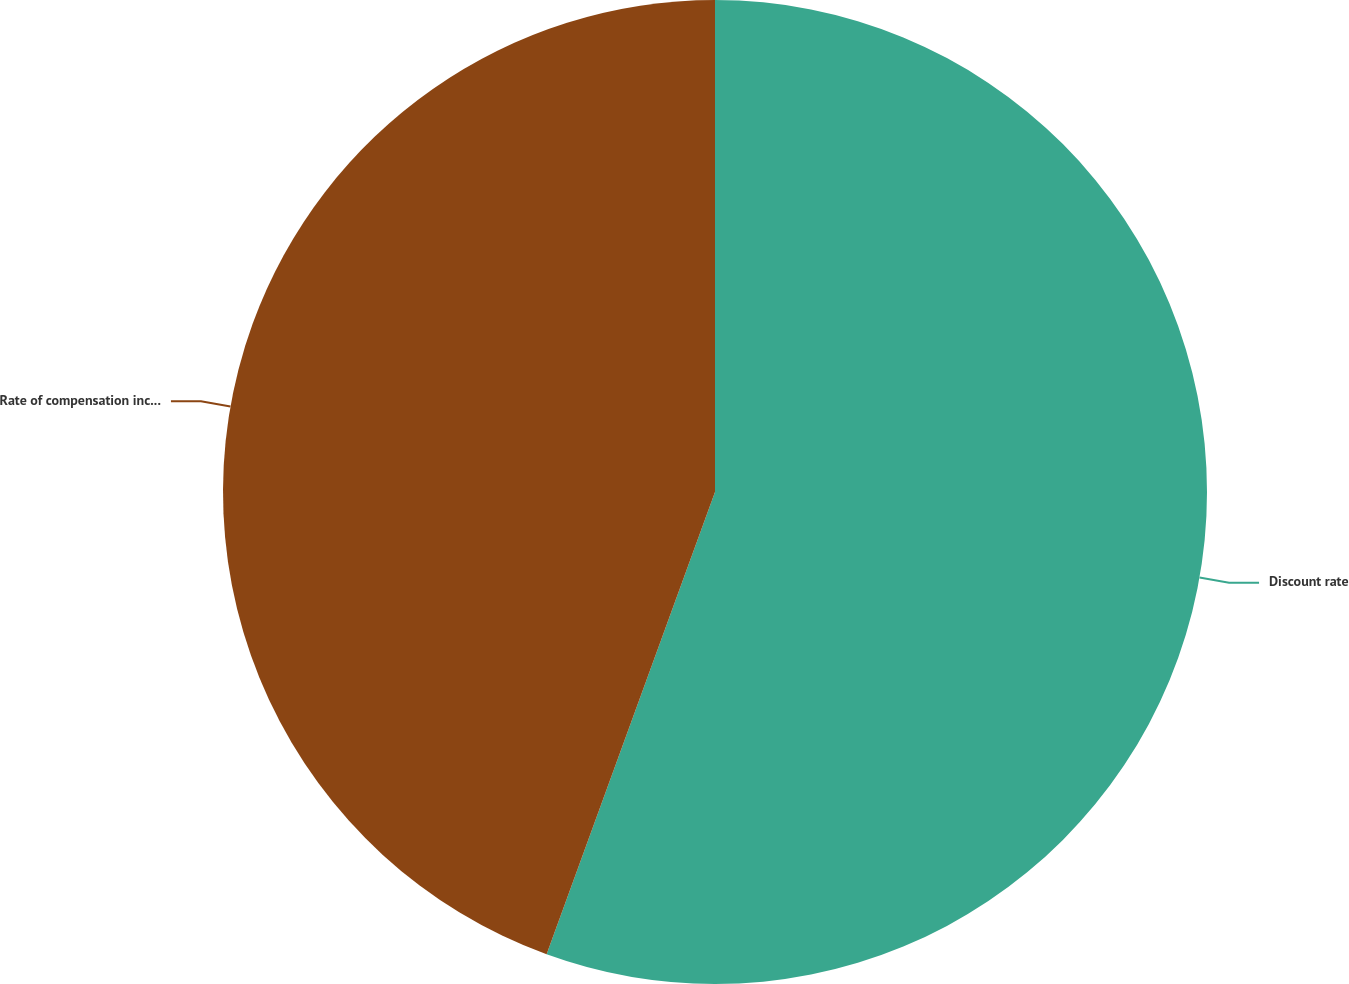Convert chart. <chart><loc_0><loc_0><loc_500><loc_500><pie_chart><fcel>Discount rate<fcel>Rate of compensation increase<nl><fcel>55.56%<fcel>44.44%<nl></chart> 